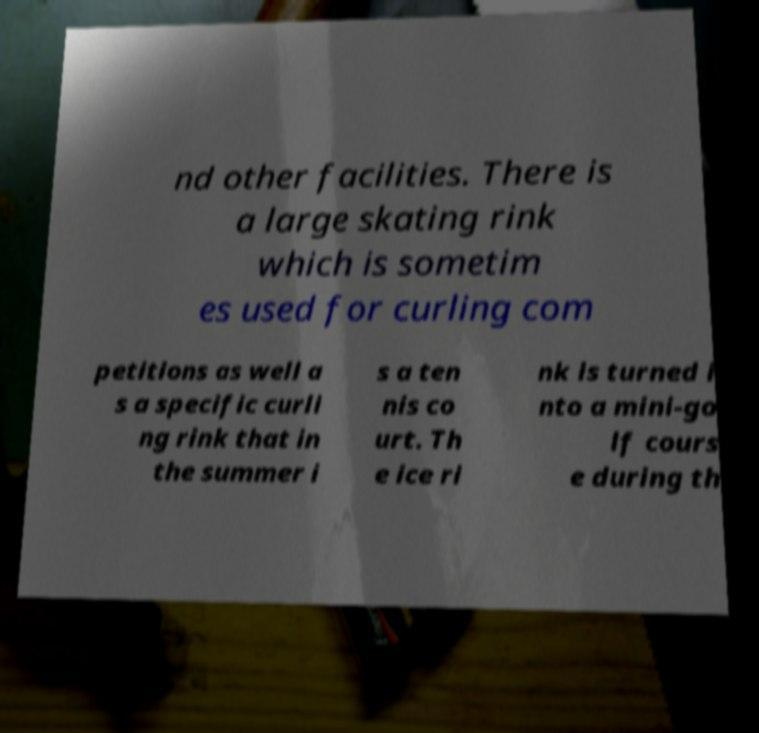Could you assist in decoding the text presented in this image and type it out clearly? nd other facilities. There is a large skating rink which is sometim es used for curling com petitions as well a s a specific curli ng rink that in the summer i s a ten nis co urt. Th e ice ri nk is turned i nto a mini-go lf cours e during th 